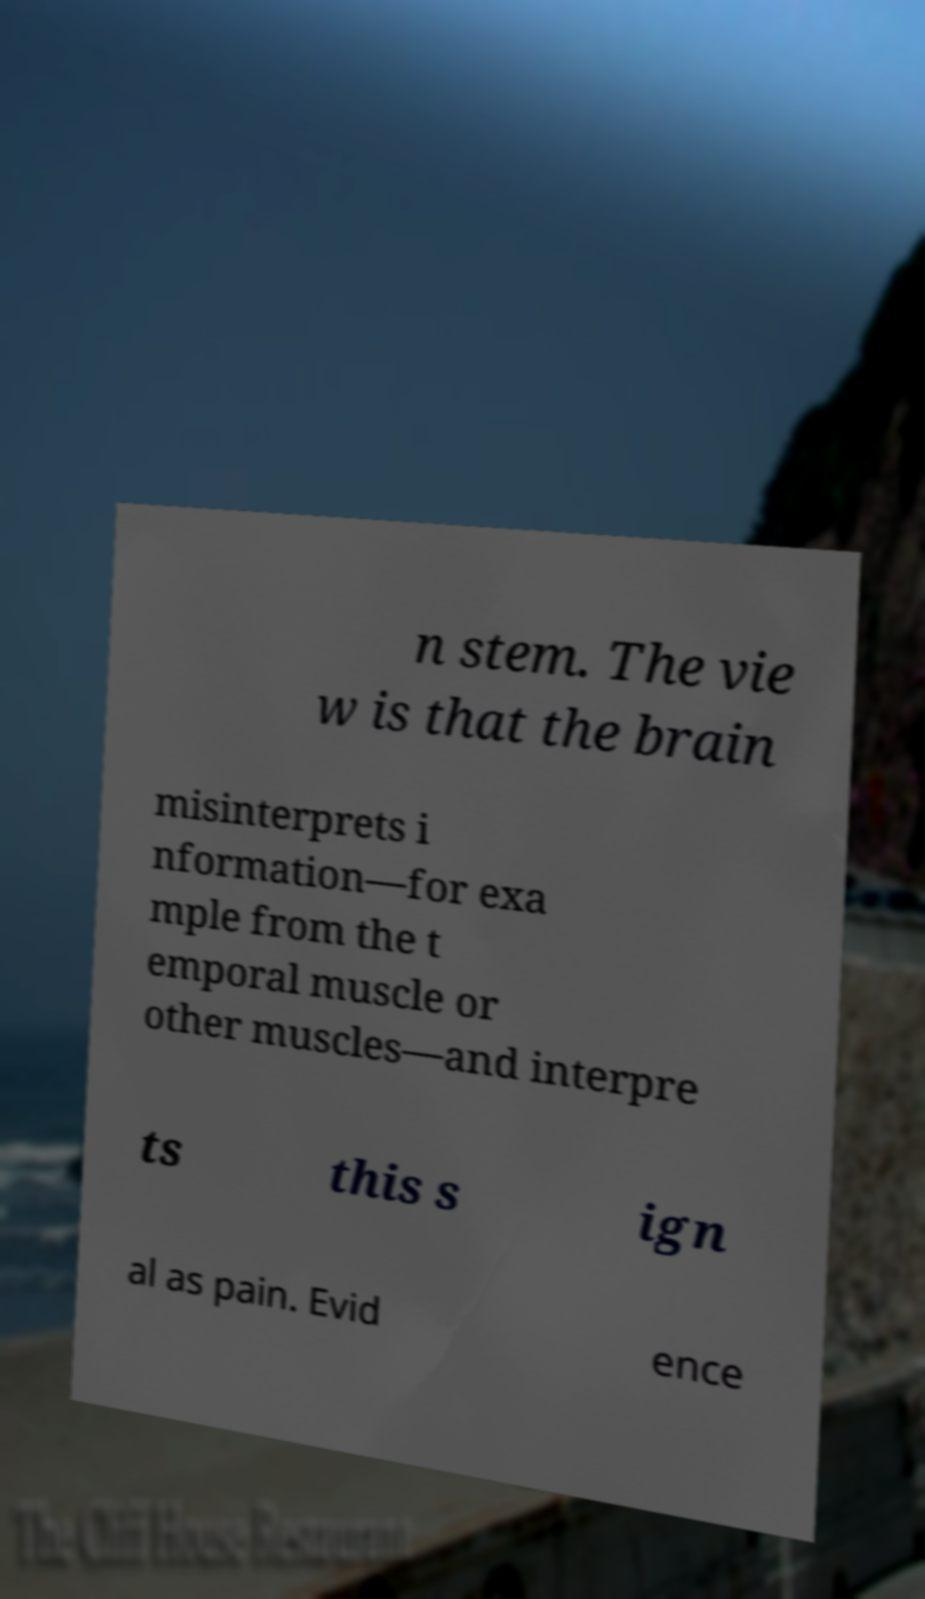Can you read and provide the text displayed in the image?This photo seems to have some interesting text. Can you extract and type it out for me? n stem. The vie w is that the brain misinterprets i nformation—for exa mple from the t emporal muscle or other muscles—and interpre ts this s ign al as pain. Evid ence 